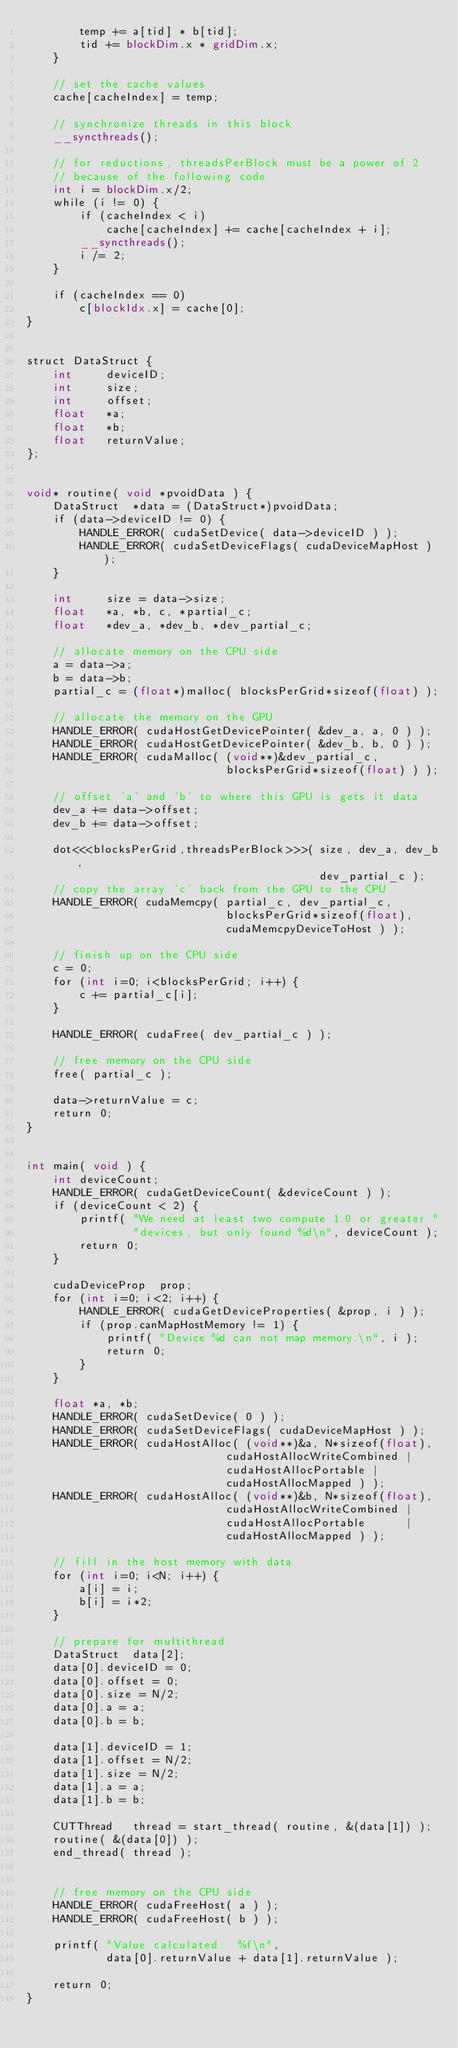<code> <loc_0><loc_0><loc_500><loc_500><_Cuda_>        temp += a[tid] * b[tid];
        tid += blockDim.x * gridDim.x;
    }
    
    // set the cache values
    cache[cacheIndex] = temp;
    
    // synchronize threads in this block
    __syncthreads();

    // for reductions, threadsPerBlock must be a power of 2
    // because of the following code
    int i = blockDim.x/2;
    while (i != 0) {
        if (cacheIndex < i)
            cache[cacheIndex] += cache[cacheIndex + i];
        __syncthreads();
        i /= 2;
    }

    if (cacheIndex == 0)
        c[blockIdx.x] = cache[0];
}


struct DataStruct {
    int     deviceID;
    int     size;
    int     offset;
    float   *a;
    float   *b;
    float   returnValue;
};


void* routine( void *pvoidData ) {
    DataStruct  *data = (DataStruct*)pvoidData;
    if (data->deviceID != 0) {
        HANDLE_ERROR( cudaSetDevice( data->deviceID ) );
        HANDLE_ERROR( cudaSetDeviceFlags( cudaDeviceMapHost ) );
    }

    int     size = data->size;
    float   *a, *b, c, *partial_c;
    float   *dev_a, *dev_b, *dev_partial_c;

    // allocate memory on the CPU side
    a = data->a;
    b = data->b;
    partial_c = (float*)malloc( blocksPerGrid*sizeof(float) );

    // allocate the memory on the GPU
    HANDLE_ERROR( cudaHostGetDevicePointer( &dev_a, a, 0 ) );
    HANDLE_ERROR( cudaHostGetDevicePointer( &dev_b, b, 0 ) );
    HANDLE_ERROR( cudaMalloc( (void**)&dev_partial_c,
                              blocksPerGrid*sizeof(float) ) );

    // offset 'a' and 'b' to where this GPU is gets it data
    dev_a += data->offset;
    dev_b += data->offset;

    dot<<<blocksPerGrid,threadsPerBlock>>>( size, dev_a, dev_b,
                                            dev_partial_c );
    // copy the array 'c' back from the GPU to the CPU
    HANDLE_ERROR( cudaMemcpy( partial_c, dev_partial_c,
                              blocksPerGrid*sizeof(float),
                              cudaMemcpyDeviceToHost ) );

    // finish up on the CPU side
    c = 0;
    for (int i=0; i<blocksPerGrid; i++) {
        c += partial_c[i];
    }

    HANDLE_ERROR( cudaFree( dev_partial_c ) );

    // free memory on the CPU side
    free( partial_c );

    data->returnValue = c;
    return 0;
}


int main( void ) {
    int deviceCount;
    HANDLE_ERROR( cudaGetDeviceCount( &deviceCount ) );
    if (deviceCount < 2) {
        printf( "We need at least two compute 1.0 or greater "
                "devices, but only found %d\n", deviceCount );
        return 0;
    }

    cudaDeviceProp  prop;
    for (int i=0; i<2; i++) {
        HANDLE_ERROR( cudaGetDeviceProperties( &prop, i ) );
        if (prop.canMapHostMemory != 1) {
            printf( "Device %d can not map memory.\n", i );
            return 0;
        }
    }

    float *a, *b;
    HANDLE_ERROR( cudaSetDevice( 0 ) );
    HANDLE_ERROR( cudaSetDeviceFlags( cudaDeviceMapHost ) );
    HANDLE_ERROR( cudaHostAlloc( (void**)&a, N*sizeof(float),
                              cudaHostAllocWriteCombined |
                              cudaHostAllocPortable |
                              cudaHostAllocMapped ) );
    HANDLE_ERROR( cudaHostAlloc( (void**)&b, N*sizeof(float),
                              cudaHostAllocWriteCombined |
                              cudaHostAllocPortable      |
                              cudaHostAllocMapped ) );

    // fill in the host memory with data
    for (int i=0; i<N; i++) {
        a[i] = i;
        b[i] = i*2;
    }

    // prepare for multithread
    DataStruct  data[2];
    data[0].deviceID = 0;
    data[0].offset = 0;
    data[0].size = N/2;
    data[0].a = a;
    data[0].b = b;

    data[1].deviceID = 1;
    data[1].offset = N/2;
    data[1].size = N/2;
    data[1].a = a;
    data[1].b = b;

    CUTThread   thread = start_thread( routine, &(data[1]) );
    routine( &(data[0]) );
    end_thread( thread );


    // free memory on the CPU side
    HANDLE_ERROR( cudaFreeHost( a ) );
    HANDLE_ERROR( cudaFreeHost( b ) );

    printf( "Value calculated:  %f\n",
            data[0].returnValue + data[1].returnValue );

    return 0;
}

</code> 